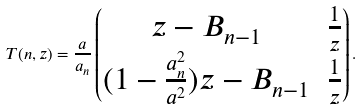<formula> <loc_0><loc_0><loc_500><loc_500>T ( n , z ) = \frac { a } { a _ { n } } \begin{pmatrix} z - B _ { n - 1 } & \frac { 1 } { z } \\ ( 1 - \frac { a _ { n } ^ { 2 } } { a ^ { 2 } } ) z - B _ { n - 1 } & \frac { 1 } { z } \end{pmatrix} .</formula> 